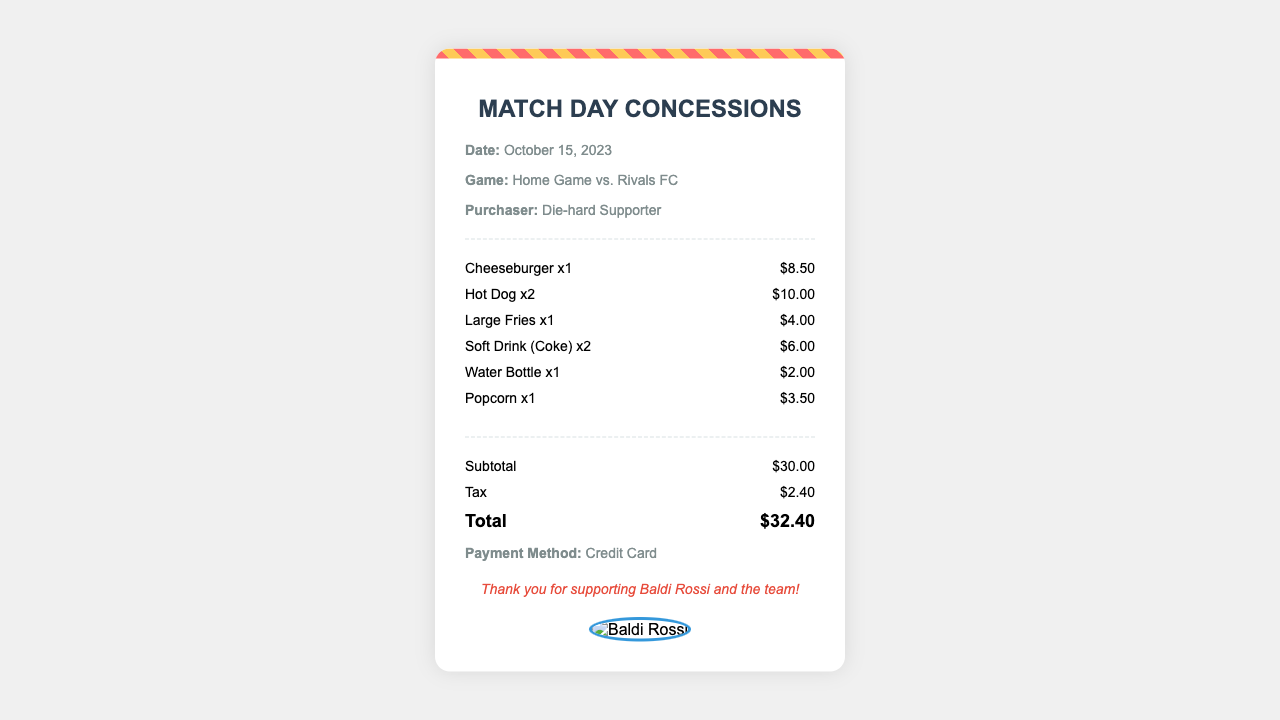What is the date of the match? The date of the match is displayed in the info section of the receipt.
Answer: October 15, 2023 What was purchased at the concession stand? The items purchased are listed in the items section of the receipt.
Answer: Cheeseburger, Hot Dog, Large Fries, Soft Drink, Water Bottle, Popcorn How many Hot Dogs were bought? The quantity of Hot Dogs is mentioned directly in the items section of the receipt.
Answer: 2 What is the subtotal of the purchases? The subtotal is calculated and provided before tax in the receipt.
Answer: $30.00 What was the total amount spent? The total amount is indicated at the bottom of the receipt after tax is added to the subtotal.
Answer: $32.40 What kind of payment method was used? The payment method is mentioned in the info section of the receipt.
Answer: Credit Card How many Soft Drinks were purchased? The number of Soft Drinks is specified in the item description.
Answer: 2 What is the tax amount? The tax amount is calculated and shown separately in the receipt.
Answer: $2.40 What is the message at the bottom of the receipt? The thank you message is located in the message section of the receipt.
Answer: Thank you for supporting Baldi Rossi and the team! 